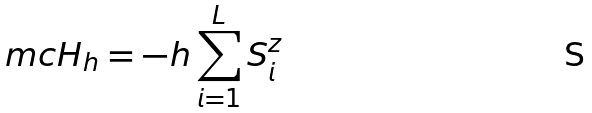Convert formula to latex. <formula><loc_0><loc_0><loc_500><loc_500>\ m c H _ { h } = - h \sum _ { i = 1 } ^ { L } S _ { i } ^ { z }</formula> 